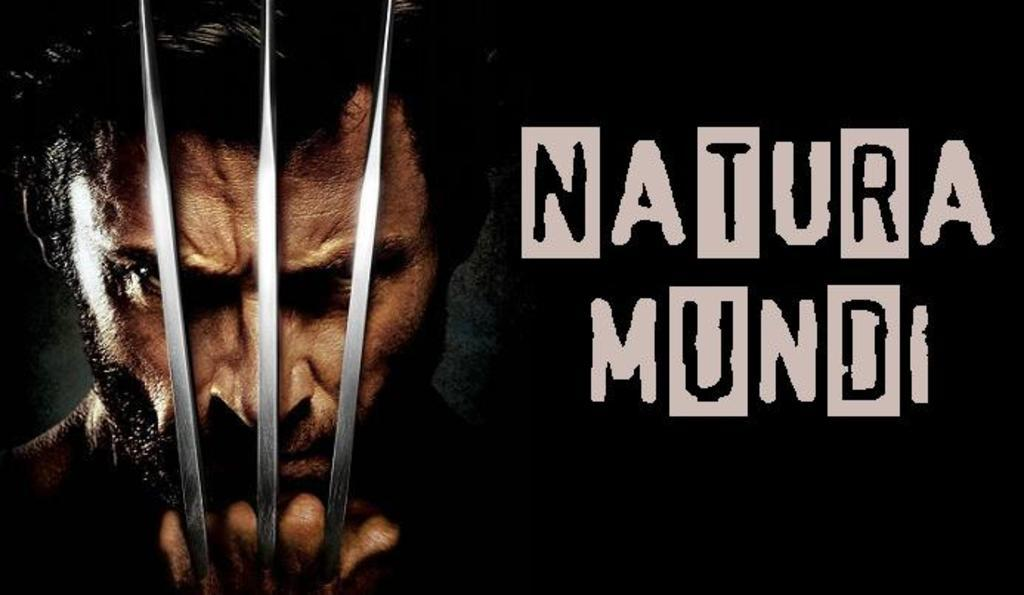What can be found in the image that contains written information? There is some text in the image. Who or what is present in the image? There is a person in the image. Where are the objects located in the image? The objects are on the left side of the image. How would you describe the background of the image? The background of the image has a dark view. What type of reward can be seen hanging from the person's neck in the image? There is no reward visible in the image; it only contains a person, text, objects, and a dark background. Is there a bike present in the image? No, there is no bike present in the image. 